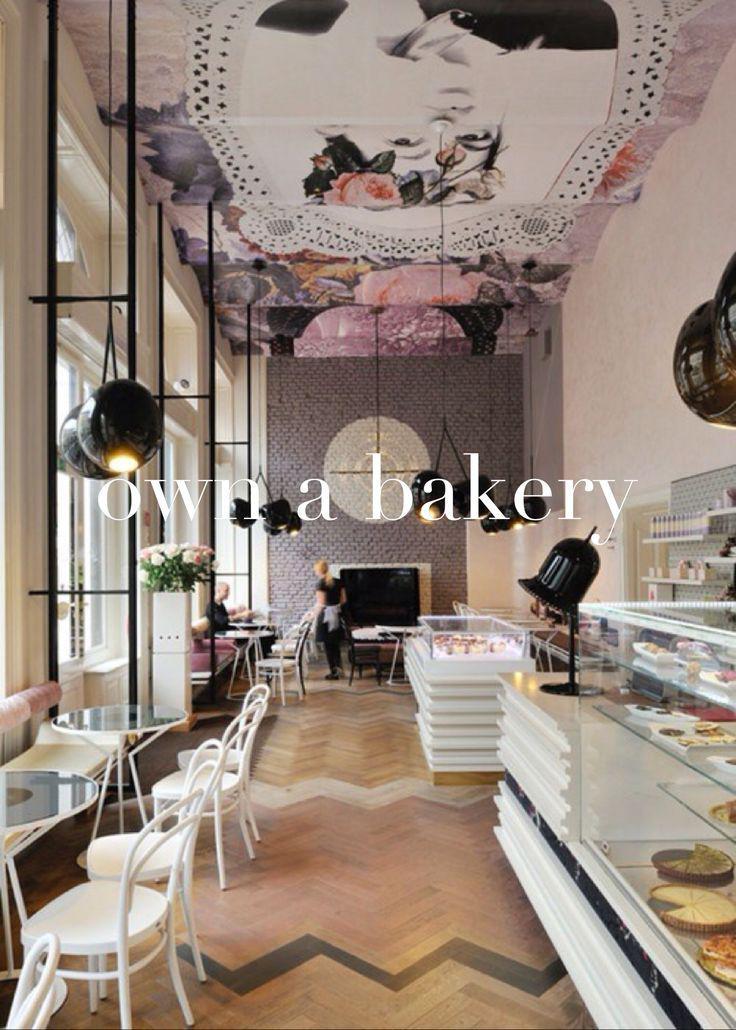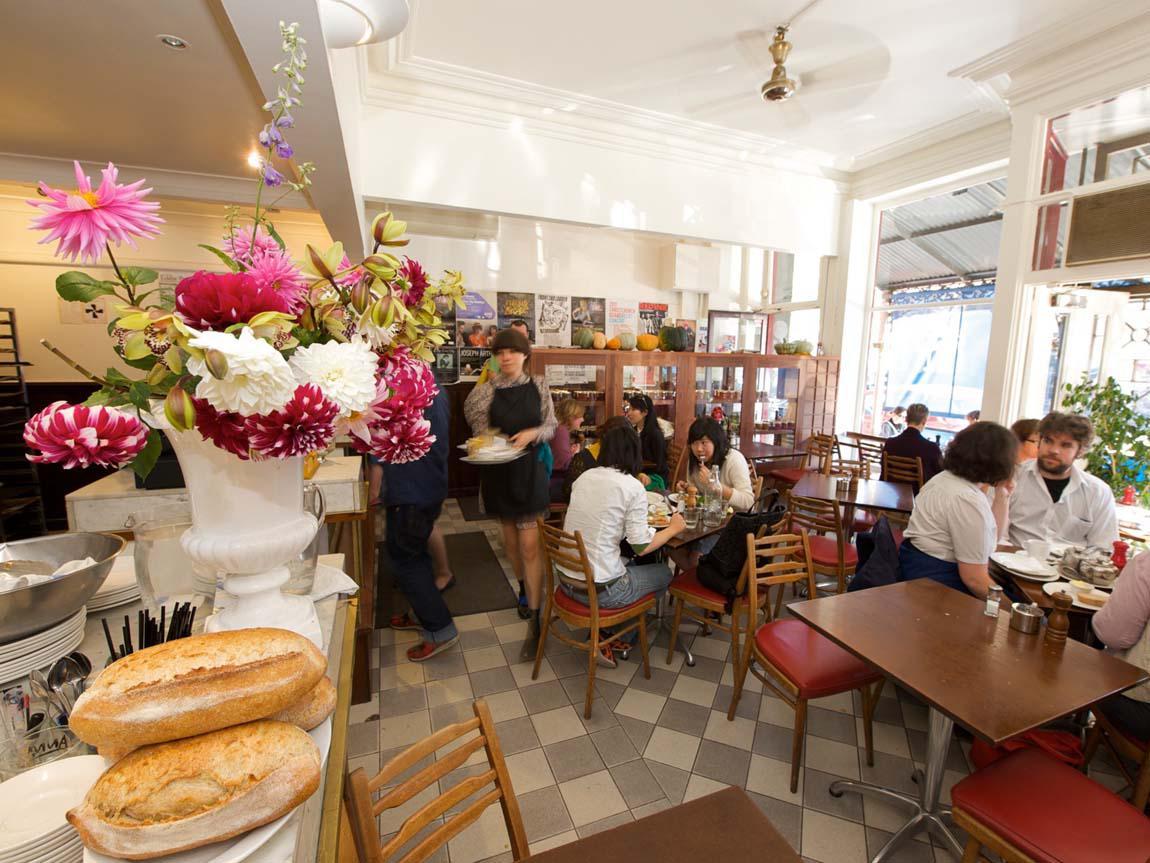The first image is the image on the left, the second image is the image on the right. For the images shown, is this caption "There are stools at the bar." true? Answer yes or no. No. The first image is the image on the left, the second image is the image on the right. Given the left and right images, does the statement "Both images in the pair show a cafe where coffee or pastries are served." hold true? Answer yes or no. Yes. 